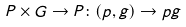<formula> <loc_0><loc_0><loc_500><loc_500>P \times G \rightarrow P \colon ( p , g ) \rightarrow p g</formula> 